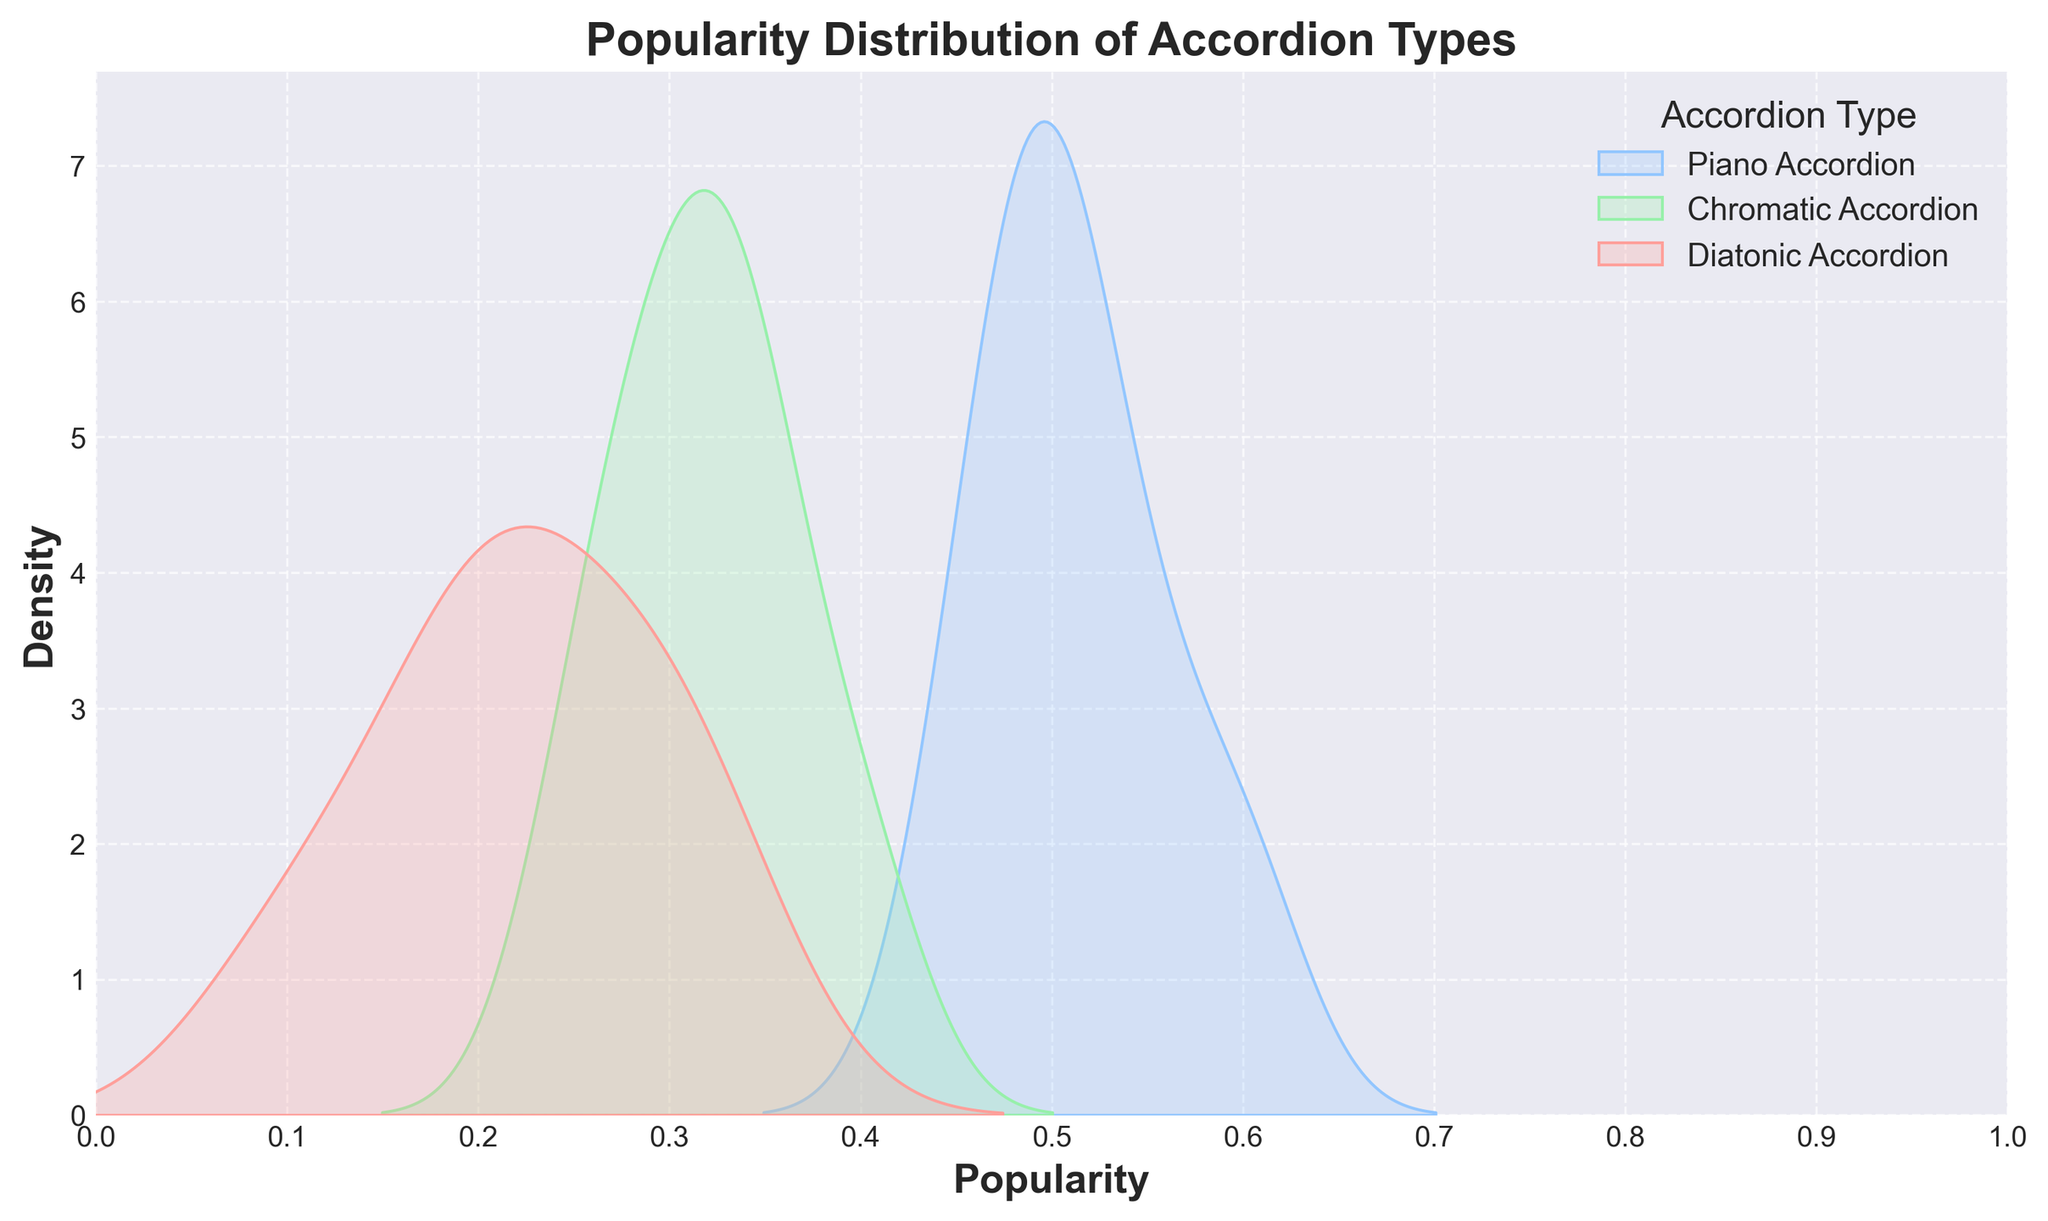How many accordion types are represented in the plot? The legend of the plot shows three distinct accordion types: Piano Accordion, Chromatic Accordion, and Diatonic Accordion.
Answer: Three What is the title of the plot? The title is located at the top of the plot and reads, "Popularity Distribution of Accordion Types".
Answer: Popularity Distribution of Accordion Types Which accordion type shows the highest peak density? By observing the density plot curves, the Piano Accordion has the highest peak density compared to Chromatic Accordion and Diatonic Accordion.
Answer: Piano Accordion Within what range does the popularity of the Diatonic Accordion fall? The Diatonic Accordion's density plot shows that its popularity values range between approximately 0.1 and 0.3.
Answer: 0.1 to 0.3 How does the popularity distribution of the Chromatic Accordion compare to that of the Diatonic Accordion? Comparing the density plots, the Chromatic Accordion's popularity distribution is wider and peaks at a higher value compared to the Diatonic Accordion, whose distribution is narrower.
Answer: Chromatic Accordion's distribution is wider and peaks higher Which accordion type has the most narrow popularity distribution? By looking at the spread of the density plots, the Diatonic Accordion's popularity distribution is the narrowest.
Answer: Diatonic Accordion What can be said about the popularity stability of Piano Accordion compared to the other types? The Piano Accordion has a broader density curve, suggesting its popularity distribution is more stable and spread across a range, unlike the more peaked and narrow distributions of other types.
Answer: More stable Are there any peaks where the popularity of any accordion types overlap? By examining the plot, there's an overlap between the density peaks of the Chromatic Accordion and Piano Accordion around the 0.3 to 0.4 popularity range.
Answer: Yes, around 0.3 to 0.4 Which accordion type has the lowest range of popularity values? From the density plots, it is evident that the Diatonic Accordion exhibits the lowest range of popularity values, roughly between 0.1 to 0.3.
Answer: Diatonic Accordion What is the range of popularity values for the Piano Accordion? By inspecting the density plot, the Piano Accordion’s popularity values range from approximately 0.45 to 0.6.
Answer: 0.45 to 0.6 